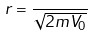Convert formula to latex. <formula><loc_0><loc_0><loc_500><loc_500>r = \frac { } { \sqrt { 2 m V _ { 0 } } }</formula> 